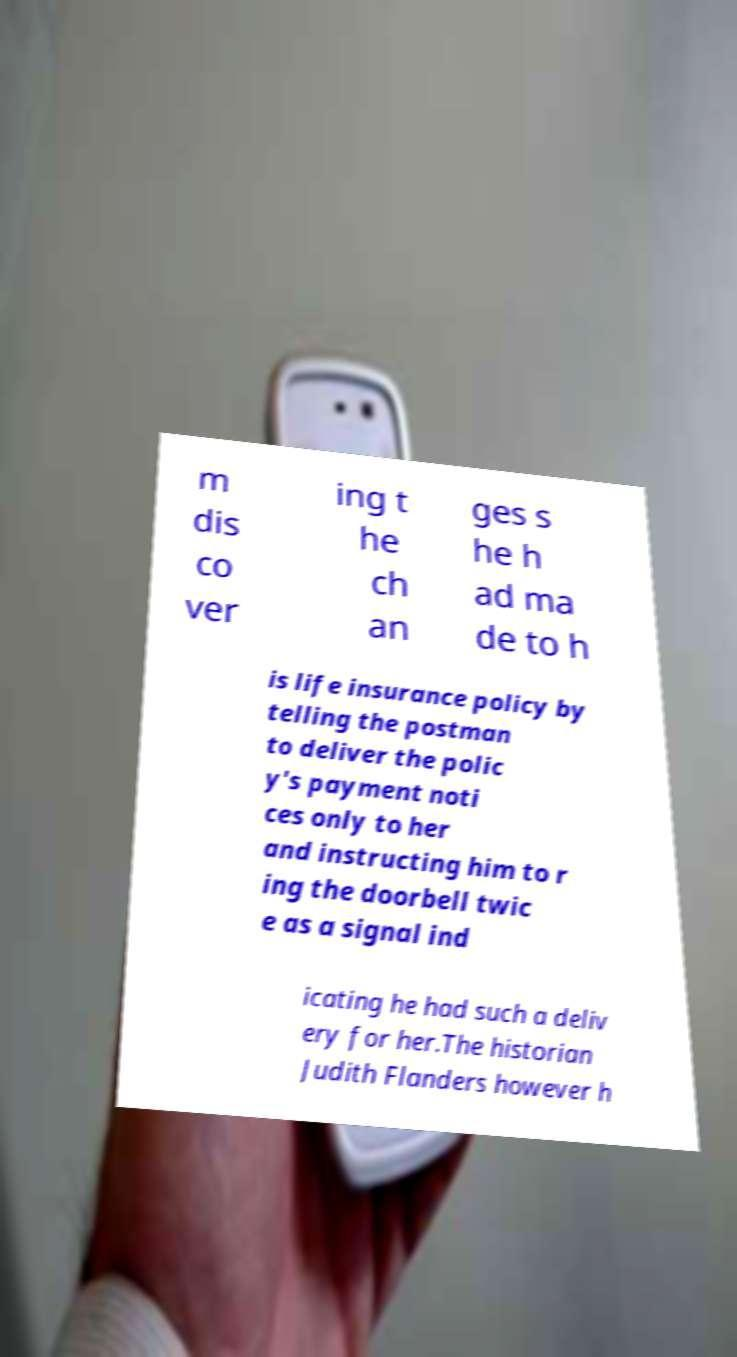There's text embedded in this image that I need extracted. Can you transcribe it verbatim? m dis co ver ing t he ch an ges s he h ad ma de to h is life insurance policy by telling the postman to deliver the polic y's payment noti ces only to her and instructing him to r ing the doorbell twic e as a signal ind icating he had such a deliv ery for her.The historian Judith Flanders however h 